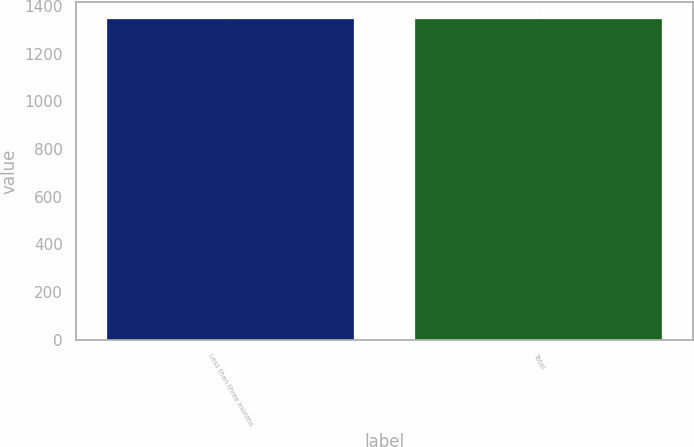Convert chart to OTSL. <chart><loc_0><loc_0><loc_500><loc_500><bar_chart><fcel>Less than three months<fcel>Total<nl><fcel>1348<fcel>1348.1<nl></chart> 